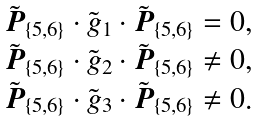<formula> <loc_0><loc_0><loc_500><loc_500>\begin{matrix} \tilde { \boldsymbol P } _ { \{ 5 , 6 \} } \cdot \tilde { g } _ { 1 } \cdot \tilde { \boldsymbol P } _ { \{ 5 , 6 \} } = 0 , \\ \tilde { \boldsymbol P } _ { \{ 5 , 6 \} } \cdot \tilde { g } _ { 2 } \cdot \tilde { \boldsymbol P } _ { \{ 5 , 6 \} } \neq 0 , \\ \tilde { \boldsymbol P } _ { \{ 5 , 6 \} } \cdot \tilde { g } _ { 3 } \cdot \tilde { \boldsymbol P } _ { \{ 5 , 6 \} } \neq 0 . \end{matrix}</formula> 